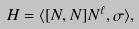<formula> <loc_0><loc_0><loc_500><loc_500>H = \langle [ N , N ] N ^ { \ell } , \sigma \rangle ,</formula> 